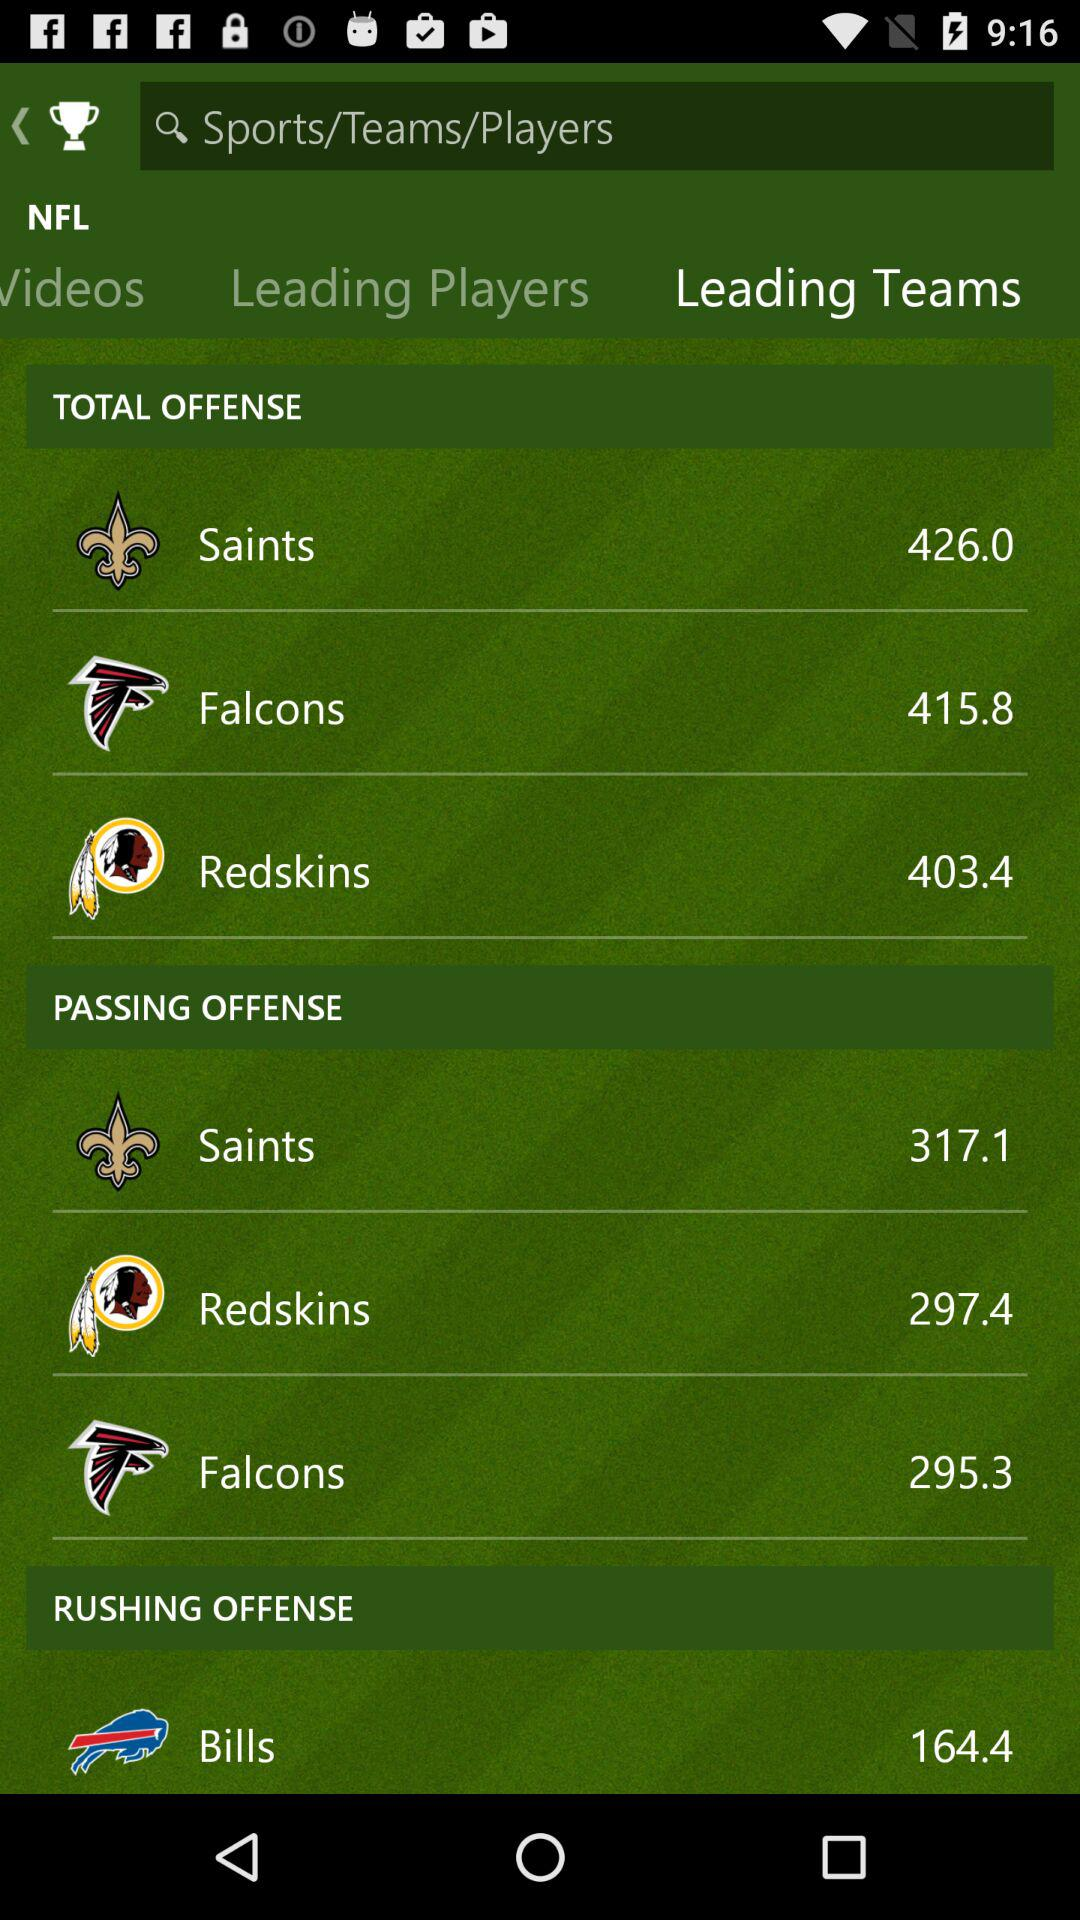Which tab is selected? The selected tab is "Leading Teams". 